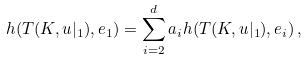<formula> <loc_0><loc_0><loc_500><loc_500>h ( T ( K , u | _ { 1 } ) , e _ { 1 } ) = \sum _ { i = 2 } ^ { d } a _ { i } h ( T ( K , u | _ { 1 } ) , e _ { i } ) \, ,</formula> 